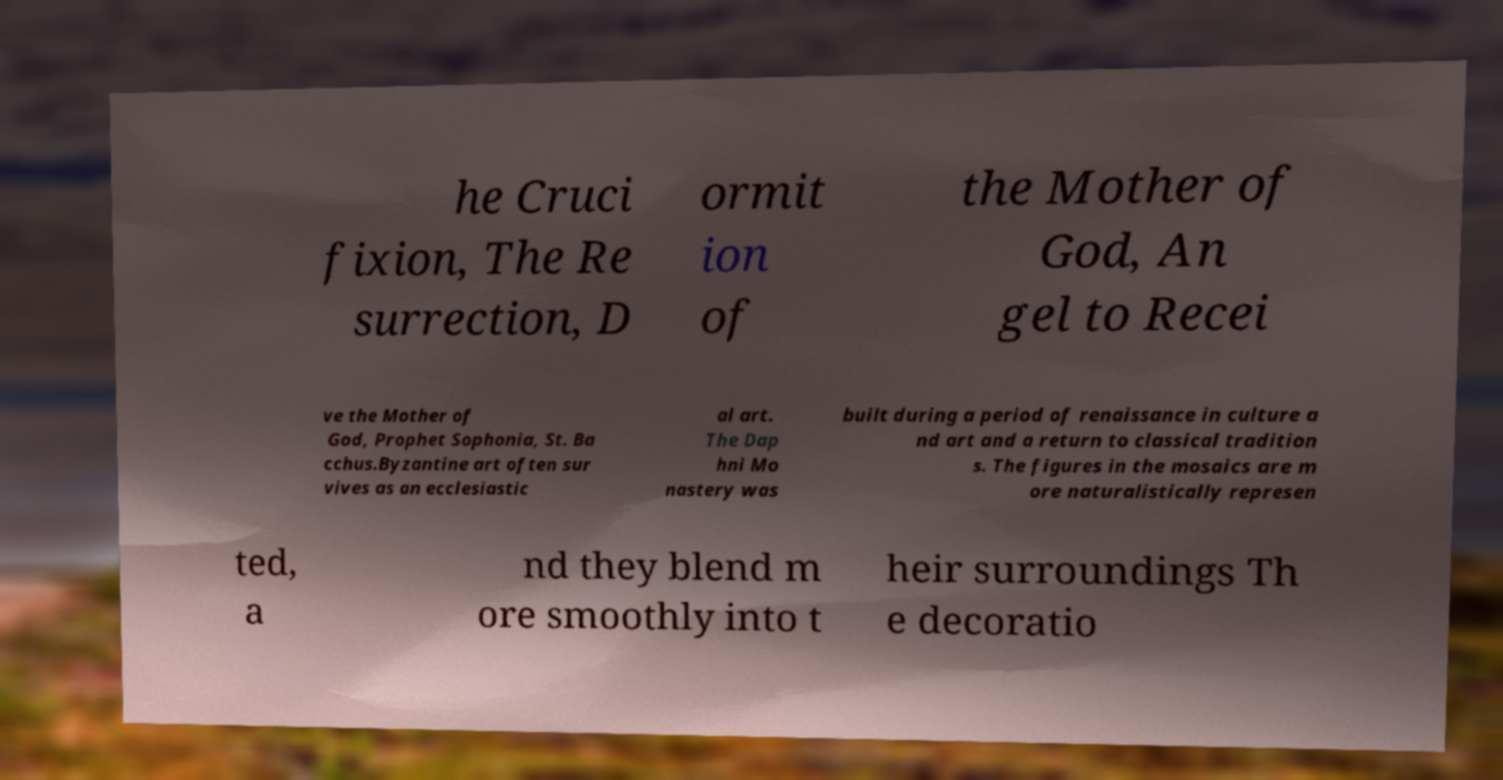Could you extract and type out the text from this image? he Cruci fixion, The Re surrection, D ormit ion of the Mother of God, An gel to Recei ve the Mother of God, Prophet Sophonia, St. Ba cchus.Byzantine art often sur vives as an ecclesiastic al art. The Dap hni Mo nastery was built during a period of renaissance in culture a nd art and a return to classical tradition s. The figures in the mosaics are m ore naturalistically represen ted, a nd they blend m ore smoothly into t heir surroundings Th e decoratio 